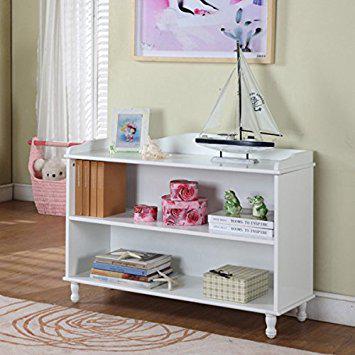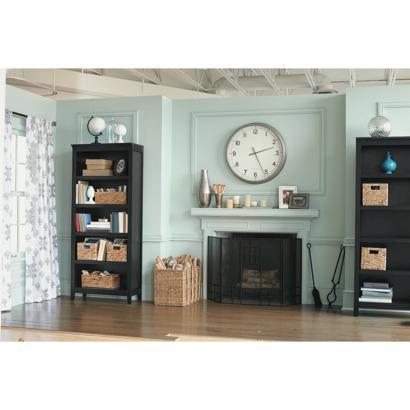The first image is the image on the left, the second image is the image on the right. For the images shown, is this caption "There is a curtain near a bookcase in at least one of the images." true? Answer yes or no. Yes. The first image is the image on the left, the second image is the image on the right. For the images shown, is this caption "Each image shows one rectangular storage unit, with no other furniture and no storage contents." true? Answer yes or no. No. 